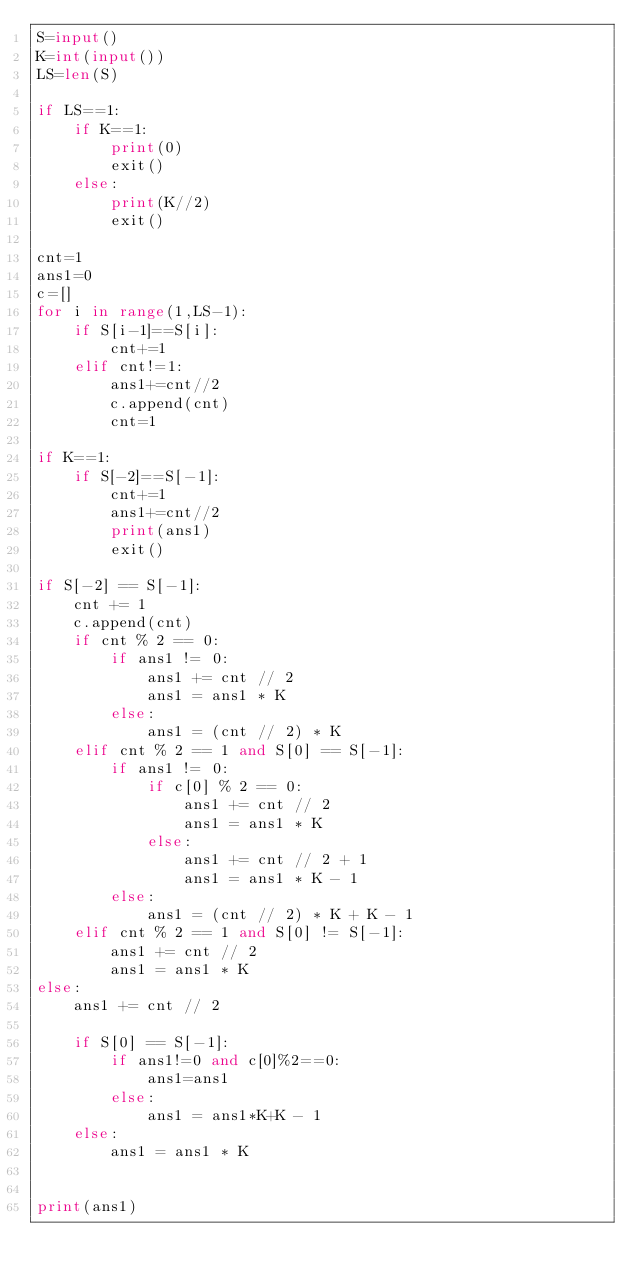Convert code to text. <code><loc_0><loc_0><loc_500><loc_500><_Python_>S=input()
K=int(input())
LS=len(S)

if LS==1:
    if K==1:
        print(0)
        exit()
    else:
        print(K//2)
        exit()

cnt=1
ans1=0
c=[]
for i in range(1,LS-1):
    if S[i-1]==S[i]:
        cnt+=1
    elif cnt!=1:
        ans1+=cnt//2
        c.append(cnt)
        cnt=1

if K==1:
    if S[-2]==S[-1]:
        cnt+=1
        ans1+=cnt//2
        print(ans1)
        exit()

if S[-2] == S[-1]:
    cnt += 1
    c.append(cnt)
    if cnt % 2 == 0:
        if ans1 != 0:
            ans1 += cnt // 2
            ans1 = ans1 * K
        else:
            ans1 = (cnt // 2) * K
    elif cnt % 2 == 1 and S[0] == S[-1]:
        if ans1 != 0:
            if c[0] % 2 == 0:
                ans1 += cnt // 2
                ans1 = ans1 * K
            else:
                ans1 += cnt // 2 + 1
                ans1 = ans1 * K - 1
        else:
            ans1 = (cnt // 2) * K + K - 1
    elif cnt % 2 == 1 and S[0] != S[-1]:
        ans1 += cnt // 2
        ans1 = ans1 * K
else:
    ans1 += cnt // 2

    if S[0] == S[-1]:
        if ans1!=0 and c[0]%2==0:
            ans1=ans1
        else:
            ans1 = ans1*K+K - 1
    else:
        ans1 = ans1 * K


print(ans1)





</code> 